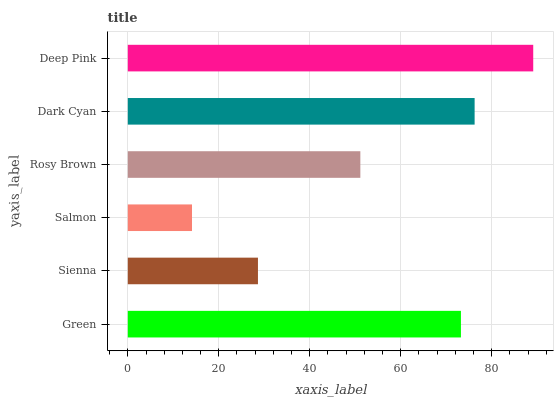Is Salmon the minimum?
Answer yes or no. Yes. Is Deep Pink the maximum?
Answer yes or no. Yes. Is Sienna the minimum?
Answer yes or no. No. Is Sienna the maximum?
Answer yes or no. No. Is Green greater than Sienna?
Answer yes or no. Yes. Is Sienna less than Green?
Answer yes or no. Yes. Is Sienna greater than Green?
Answer yes or no. No. Is Green less than Sienna?
Answer yes or no. No. Is Green the high median?
Answer yes or no. Yes. Is Rosy Brown the low median?
Answer yes or no. Yes. Is Salmon the high median?
Answer yes or no. No. Is Dark Cyan the low median?
Answer yes or no. No. 